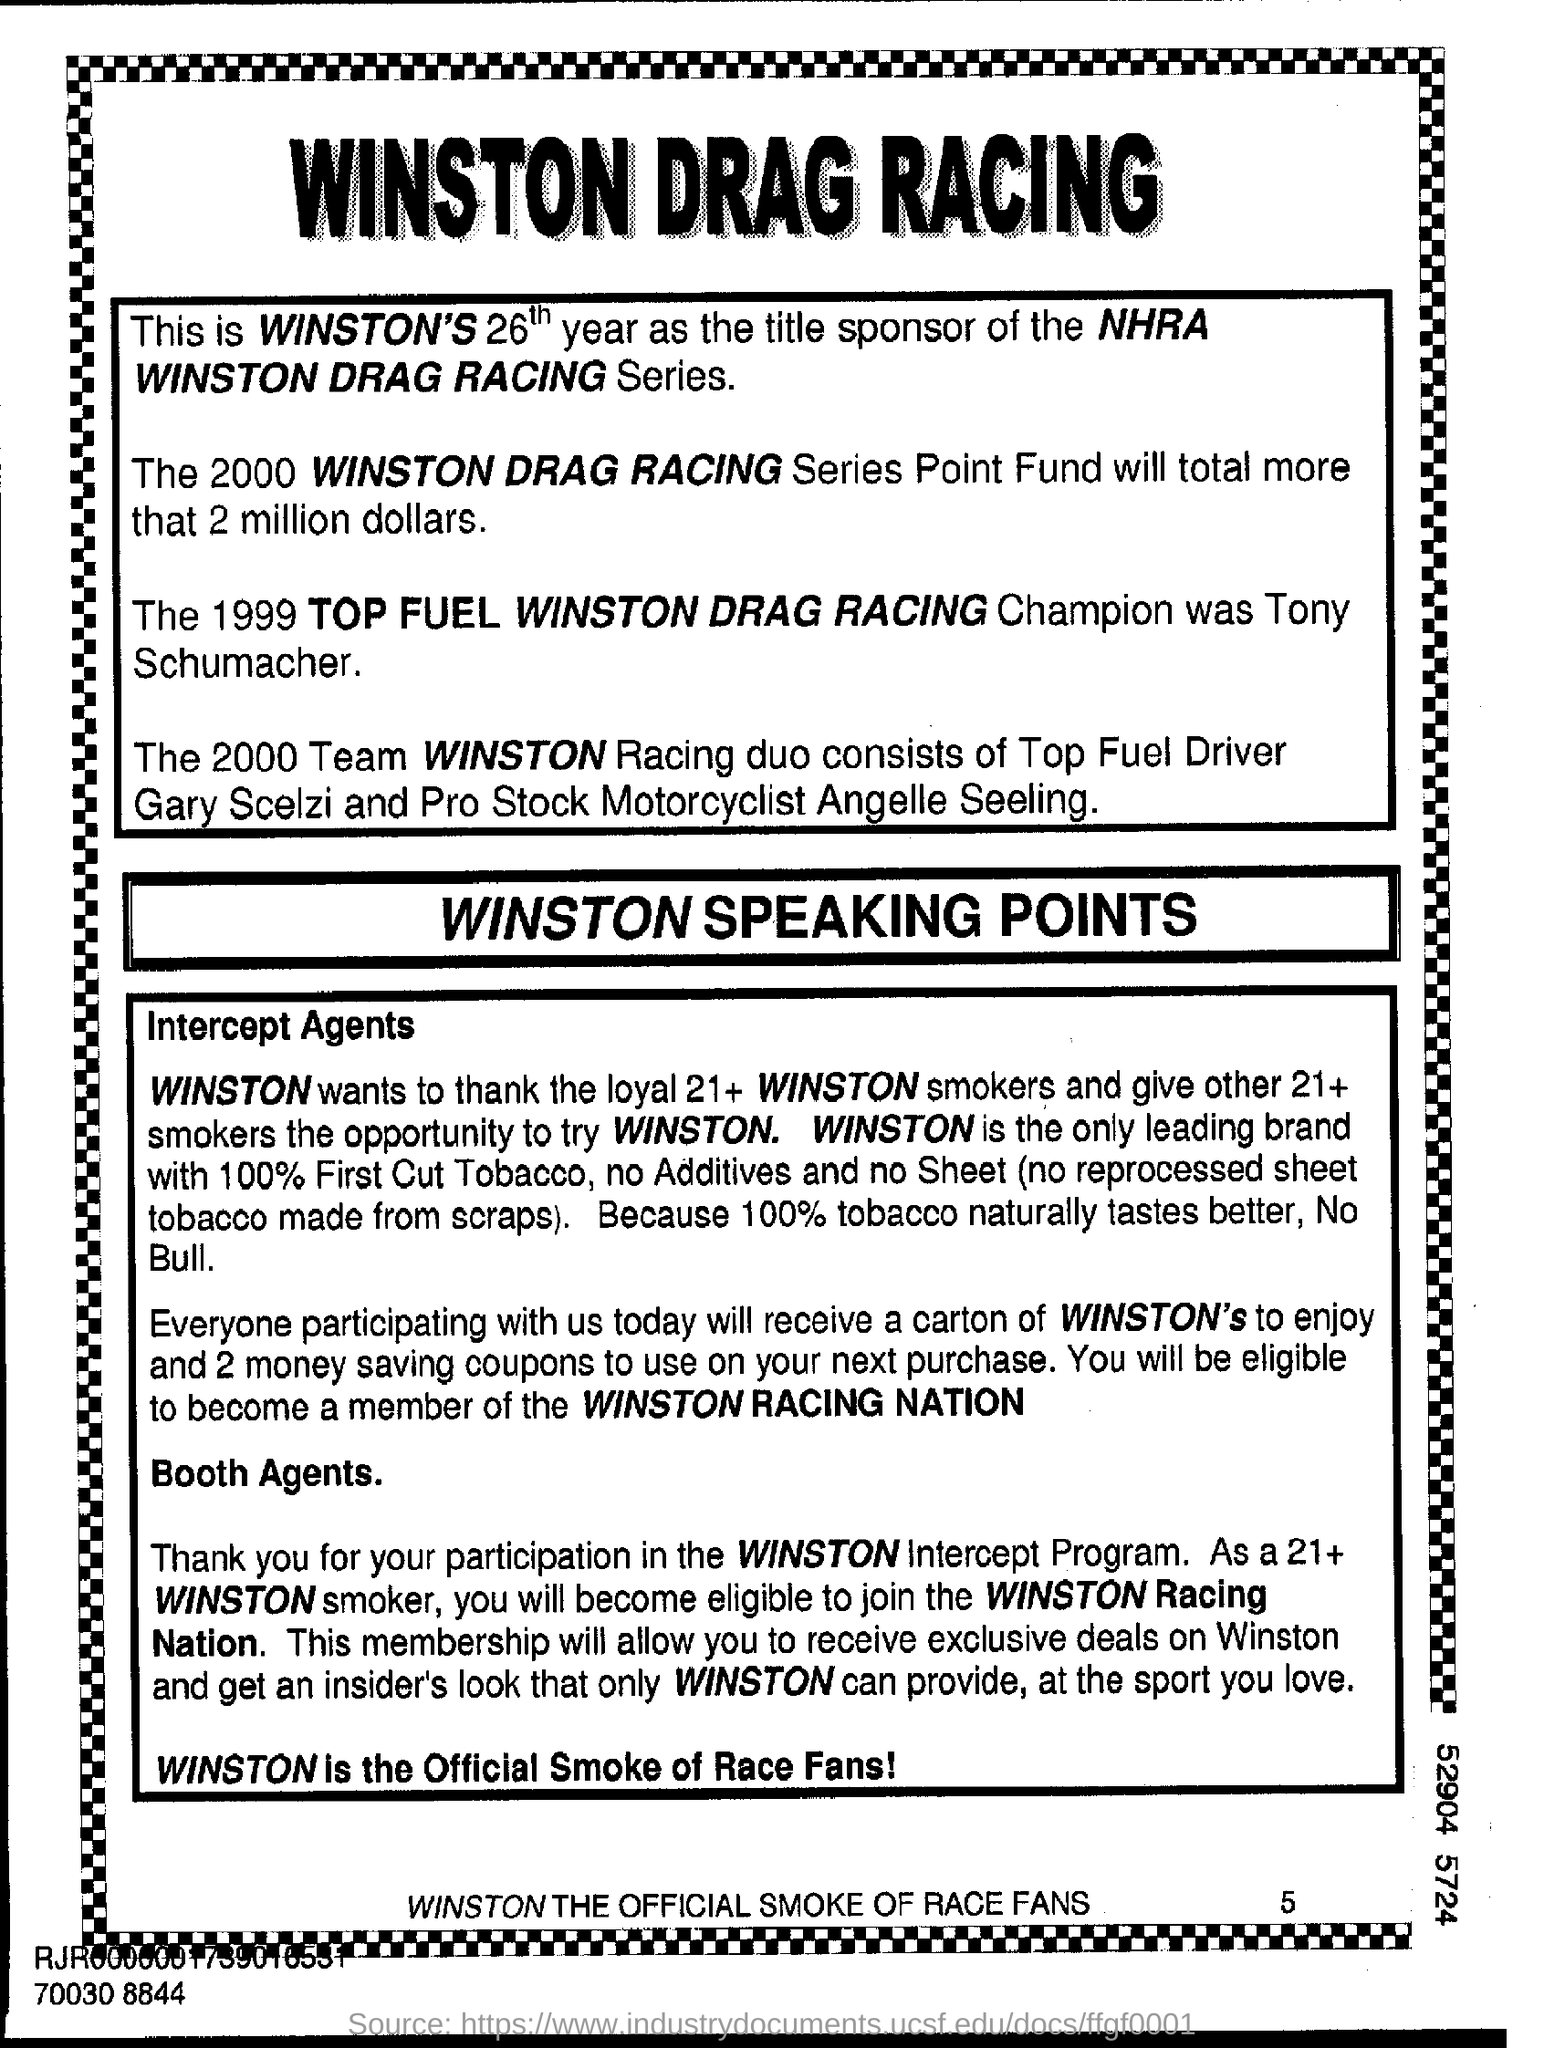Draw attention to some important aspects in this diagram. Tony Schumacher is the 1999 Top Fuel Winston Drag Racing Champion. The Winston Drag Racing Series is the title sponsored by Winston. 